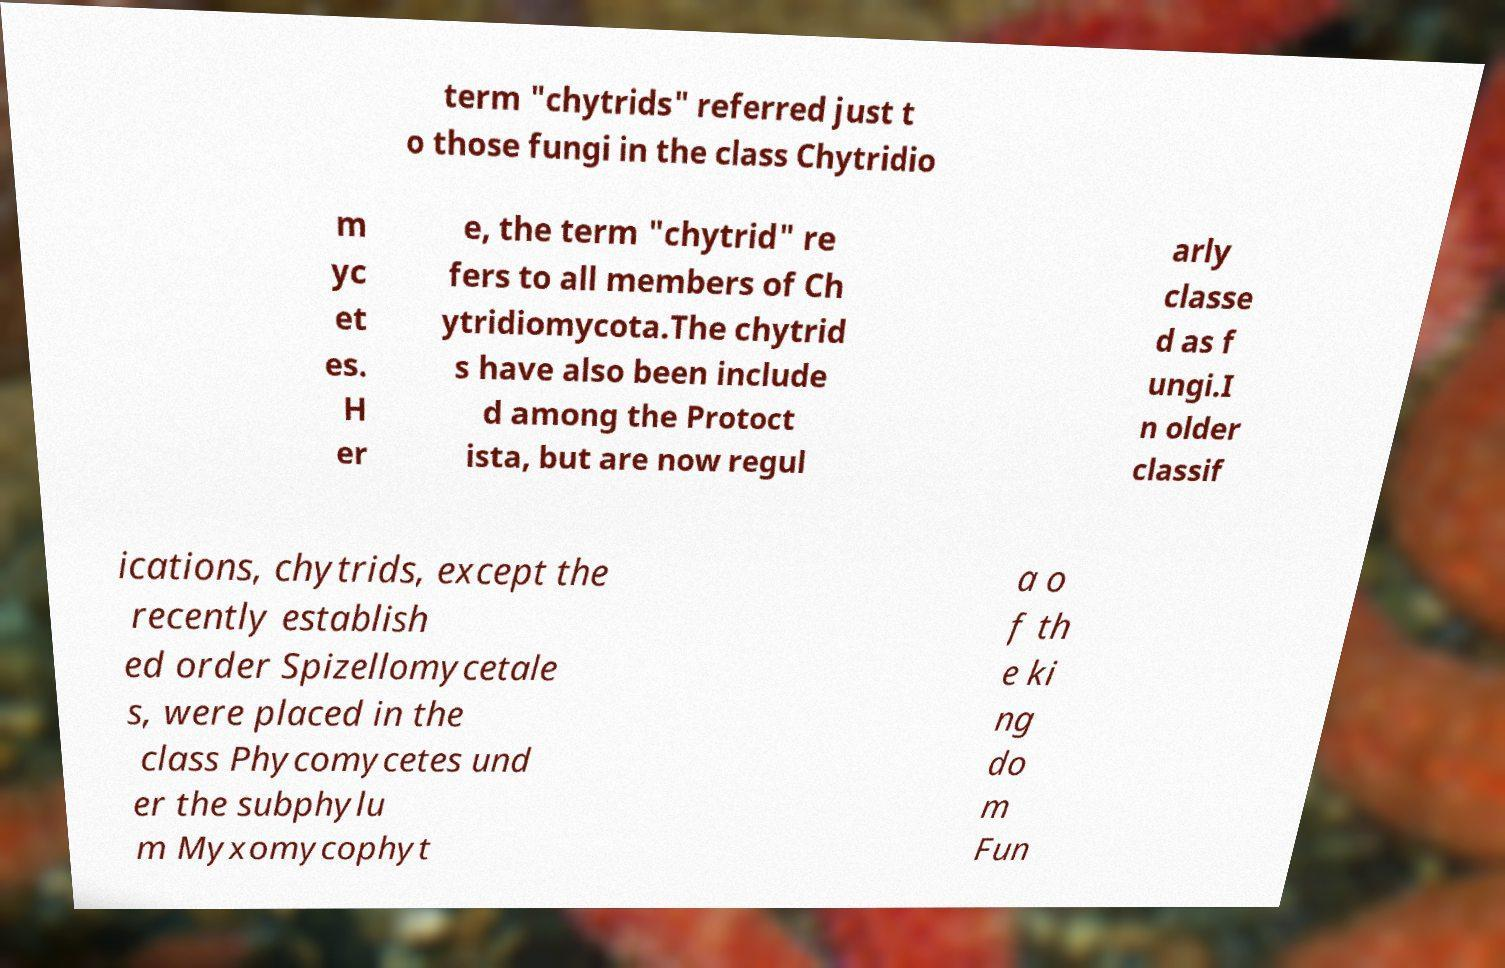Please read and relay the text visible in this image. What does it say? term "chytrids" referred just t o those fungi in the class Chytridio m yc et es. H er e, the term "chytrid" re fers to all members of Ch ytridiomycota.The chytrid s have also been include d among the Protoct ista, but are now regul arly classe d as f ungi.I n older classif ications, chytrids, except the recently establish ed order Spizellomycetale s, were placed in the class Phycomycetes und er the subphylu m Myxomycophyt a o f th e ki ng do m Fun 